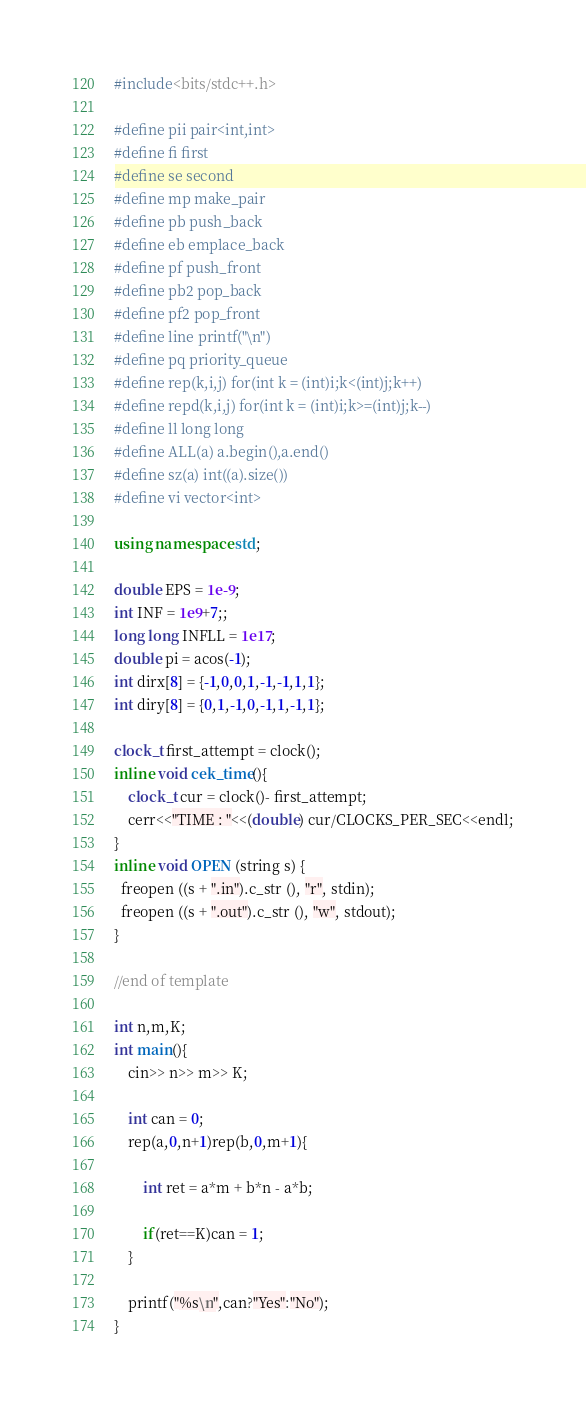<code> <loc_0><loc_0><loc_500><loc_500><_C++_>#include<bits/stdc++.h>

#define pii pair<int,int>
#define fi first
#define se second
#define mp make_pair
#define pb push_back
#define eb emplace_back
#define pf push_front
#define pb2 pop_back
#define pf2 pop_front
#define line printf("\n")
#define pq priority_queue
#define rep(k,i,j) for(int k = (int)i;k<(int)j;k++)
#define repd(k,i,j) for(int k = (int)i;k>=(int)j;k--)
#define ll long long
#define ALL(a) a.begin(),a.end()
#define sz(a) int((a).size())
#define vi vector<int>

using namespace std;

double EPS = 1e-9;
int INF = 1e9+7;;
long long INFLL = 1e17;
double pi = acos(-1);
int dirx[8] = {-1,0,0,1,-1,-1,1,1};
int diry[8] = {0,1,-1,0,-1,1,-1,1};

clock_t first_attempt = clock();
inline void cek_time(){
	clock_t cur = clock()- first_attempt;
	cerr<<"TIME : "<<(double) cur/CLOCKS_PER_SEC<<endl;
}
inline void OPEN (string s) {
  freopen ((s + ".in").c_str (), "r", stdin);
  freopen ((s + ".out").c_str (), "w", stdout);
}

//end of template

int n,m,K;
int main(){
    cin>> n>> m>> K;
    
    int can = 0;
    rep(a,0,n+1)rep(b,0,m+1){
        
        int ret = a*m + b*n - a*b;
        
        if(ret==K)can = 1;
    }
    
    printf("%s\n",can?"Yes":"No");
}</code> 